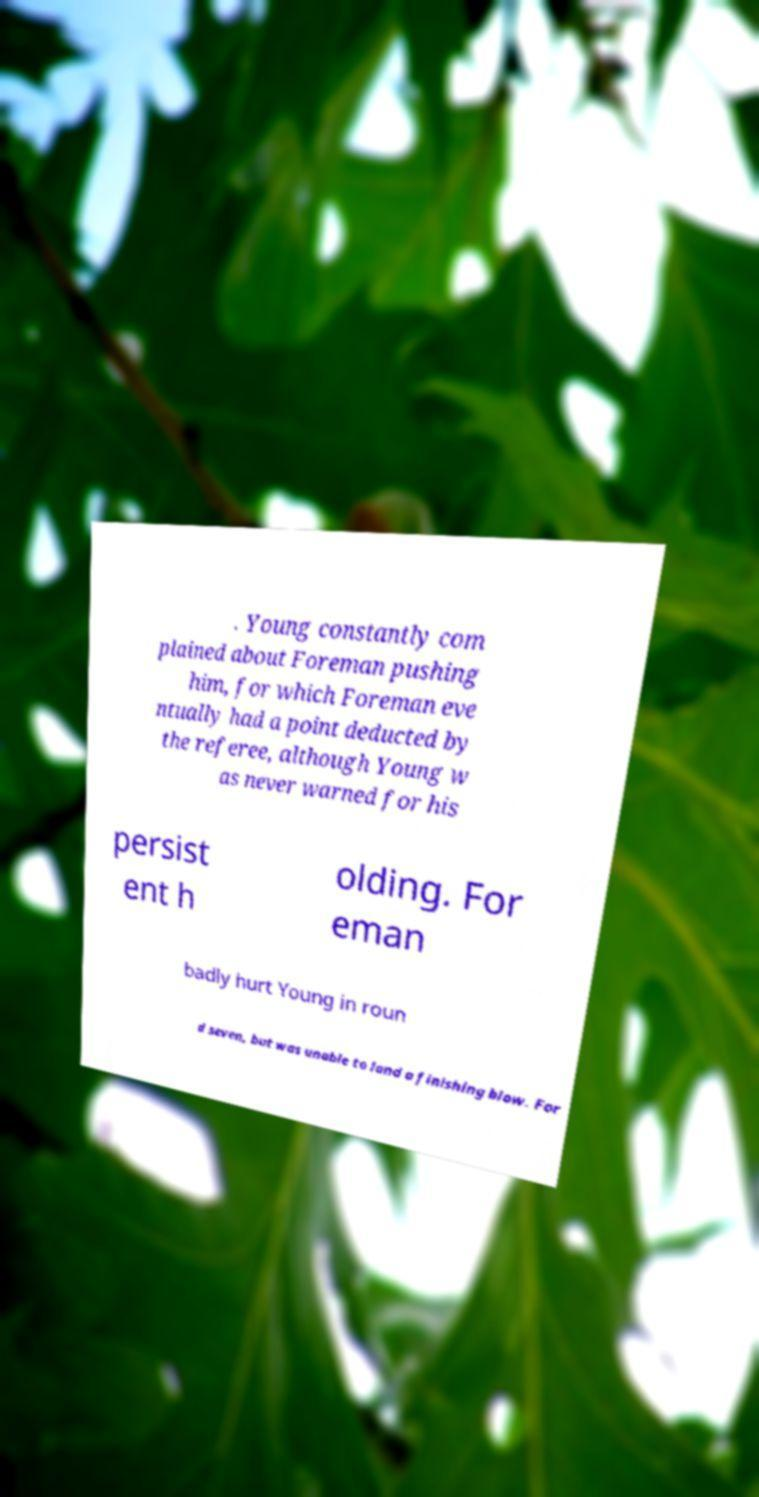Can you read and provide the text displayed in the image?This photo seems to have some interesting text. Can you extract and type it out for me? . Young constantly com plained about Foreman pushing him, for which Foreman eve ntually had a point deducted by the referee, although Young w as never warned for his persist ent h olding. For eman badly hurt Young in roun d seven, but was unable to land a finishing blow. For 